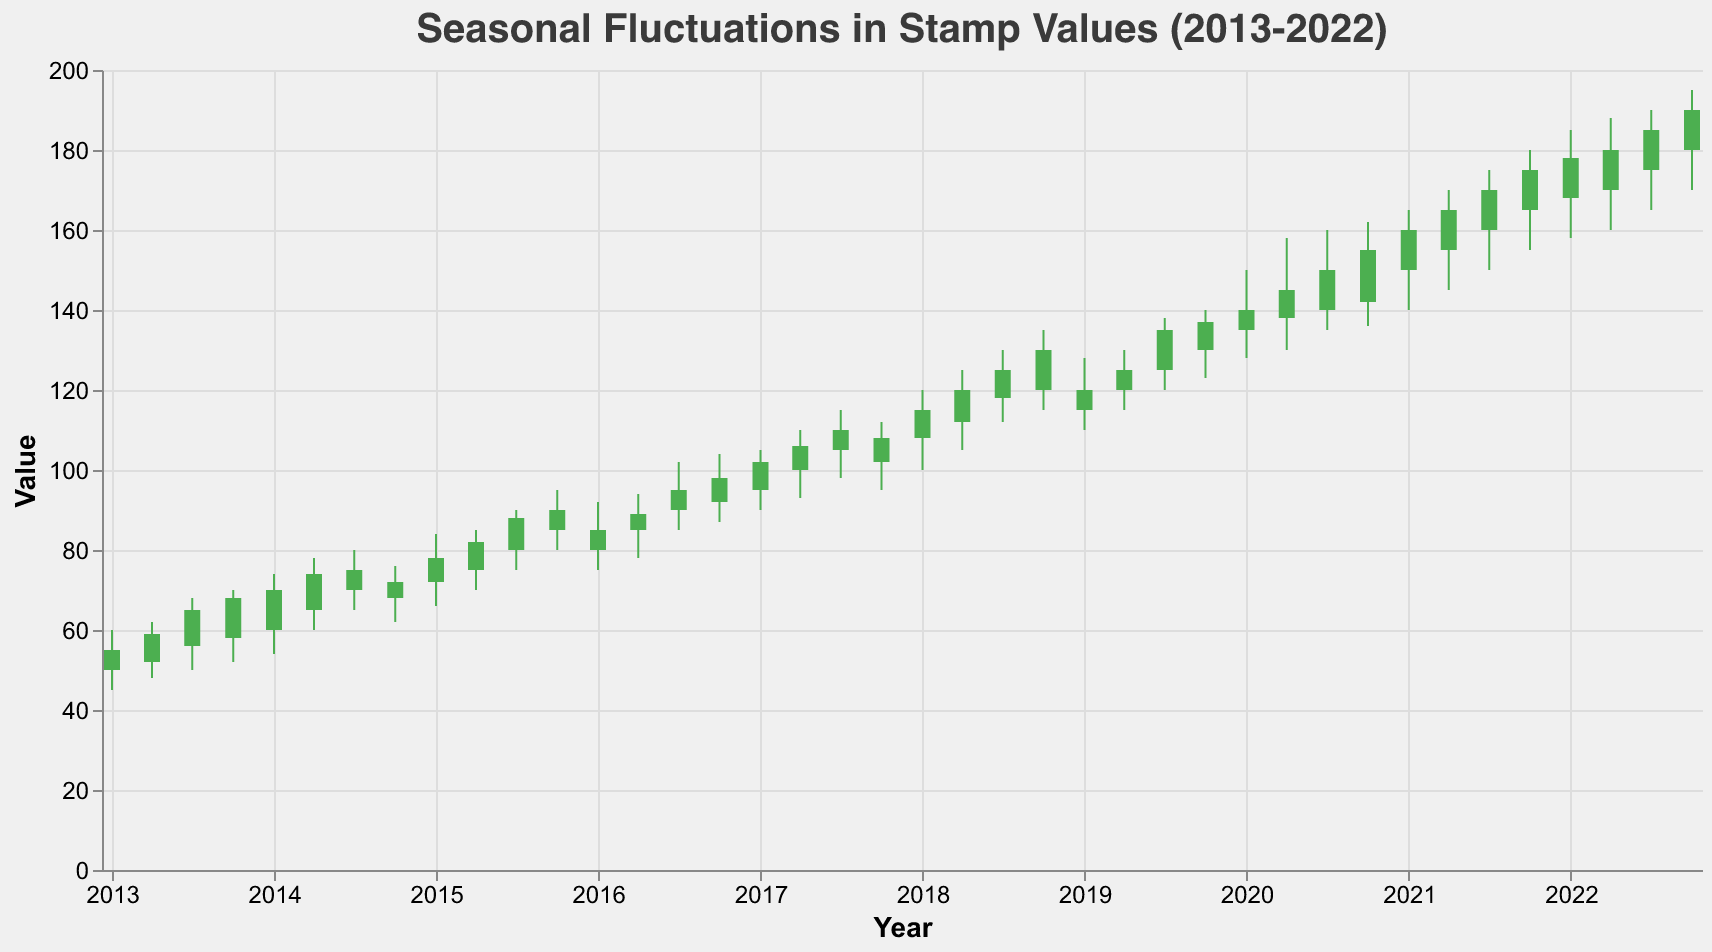What is the title of the figure? The title is usually displayed prominently at the top of the figure. In this case, the title reads "Seasonal Fluctuations in Stamp Values (2013-2022)".
Answer: Seasonal Fluctuations in Stamp Values (2013-2022) How much did the value of the "Starry Night by Vincent van Gogh" stamp increase from January 2013 to January 2022? To find the increase, subtract the closing value in January 2013 from the closing value in January 2022. January 2013 closing value is 55, and January 2022 closing value is 178. The increase is 178 - 55 = 123.
Answer: 123 Which stamp had the peak value in July 2022? By looking at the high values in July 2022, the stamp with the highest peak value is the "Mona Lisa by Leonardo da Vinci" with a peak value of 190.
Answer: Mona Lisa by Leonardo da Vinci What is the trend observed in the value of stamps over the given decade? Observing the candlestick plots from 2013 to 2022, it’s clear that overall stamp values have been increasing. The lows, highs, opens, and closes generally trend upward over the decade.
Answer: Increasing trend In which season does the "Guernica by Pablo Picasso" stamp typically have the highest close values? By checking the closing values for "Guernica by Pablo Picasso" across different seasons, it peaks each time in January: 78 in 2015, 115 in 2018, and 160 in 2021.
Answer: Winter Which stamps show a significant rise in value during January 2017 compared to January 2016? Comparing January 2017 to January 2016, "The Kiss by Gustav Klimt" increased from 85 to 102, and "Starry Night by Vincent van Gogh" increased from 85 to 102 as well. Both show significant increments.
Answer: The Kiss by Gustav Klimt, Starry Night by Vincent van Gogh What is the average closing value of the "Mona Lisa by Leonardo da Vinci" stamp in all recorded April months? Calculate the average of closing values in April: (65 + 95 + 110 + 125 + 135 + 165 + 185) / 7 = 880 / 7 = 125.71
Answer: 125.71 Which seasons typically witness the lowest low values for the stamps? By examining the lowest values, most stamps hit their lowest points in January (45, 54, 66, 75, 90, 110, 140, 158). Specifically, lowest lows are in January for majority stamps.
Answer: Winter Is there a color difference in the bars representing stamps where the value increased versus decreased? Yes, the color condition in the encoding indicates that green (#4CAF50) represents an increase (Open < Close), and red (#F44336) represents a decrease (Open > Close).
Answer: Yes How does the stamp "Water Lilies by Claude Monet" perform seasonally throughout the years? Analyzing its performance, "Water Lilies by Claude Monet" shows consistent increases in value, peaking higher each year, particularly with high closing values in July and relatively stable increases across all seasons.
Answer: Consistent increase 